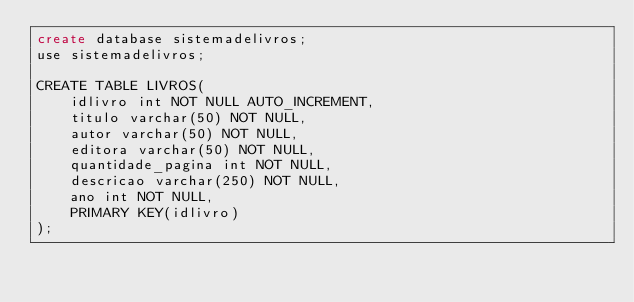<code> <loc_0><loc_0><loc_500><loc_500><_SQL_>create database sistemadelivros;
use sistemadelivros;

CREATE TABLE LIVROS(
    idlivro int NOT NULL AUTO_INCREMENT,
    titulo varchar(50) NOT NULL,
    autor varchar(50) NOT NULL,
    editora varchar(50) NOT NULL,
    quantidade_pagina int NOT NULL,
    descricao varchar(250) NOT NULL,
    ano int NOT NULL,
    PRIMARY KEY(idlivro)
);</code> 